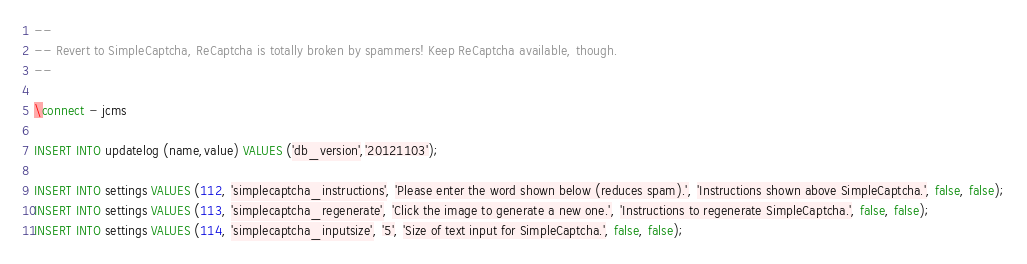<code> <loc_0><loc_0><loc_500><loc_500><_SQL_>--
-- Revert to SimpleCaptcha, ReCaptcha is totally broken by spammers! Keep ReCaptcha available, though.
--

\connect - jcms

INSERT INTO updatelog (name,value) VALUES ('db_version','20121103');

INSERT INTO settings VALUES (112, 'simplecaptcha_instructions', 'Please enter the word shown below (reduces spam).', 'Instructions shown above SimpleCaptcha.', false, false);
INSERT INTO settings VALUES (113, 'simplecaptcha_regenerate', 'Click the image to generate a new one.', 'Instructions to regenerate SimpleCaptcha.', false, false);
INSERT INTO settings VALUES (114, 'simplecaptcha_inputsize', '5', 'Size of text input for SimpleCaptcha.', false, false);

</code> 